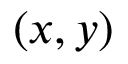<formula> <loc_0><loc_0><loc_500><loc_500>( x , y )</formula> 